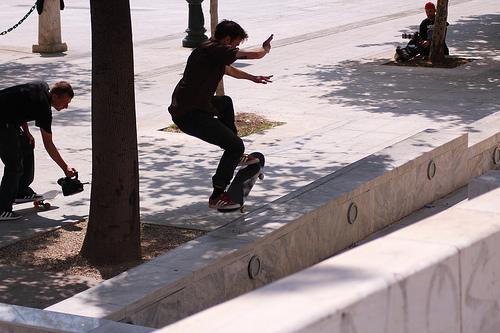How many people are there?
Give a very brief answer. 3. 